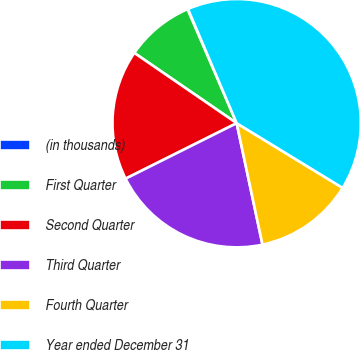Convert chart. <chart><loc_0><loc_0><loc_500><loc_500><pie_chart><fcel>(in thousands)<fcel>First Quarter<fcel>Second Quarter<fcel>Third Quarter<fcel>Fourth Quarter<fcel>Year ended December 31<nl><fcel>0.07%<fcel>8.94%<fcel>16.95%<fcel>20.96%<fcel>12.94%<fcel>40.14%<nl></chart> 